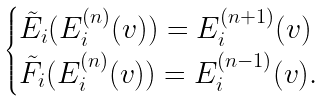<formula> <loc_0><loc_0><loc_500><loc_500>\begin{cases} \tilde { E } _ { i } ( E _ { i } ^ { ( n ) } ( v ) ) = E _ { i } ^ { ( n + 1 ) } ( v ) \\ \tilde { F } _ { i } ( E _ { i } ^ { ( n ) } ( v ) ) = E _ { i } ^ { ( n - 1 ) } ( v ) . \end{cases}</formula> 